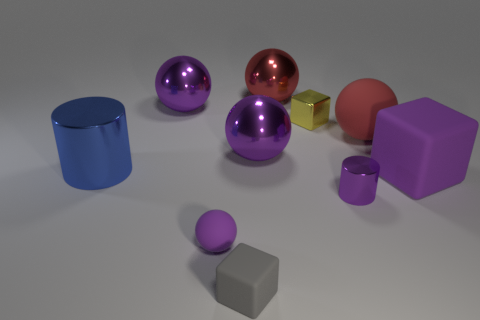Subtract all purple balls. How many were subtracted if there are1purple balls left? 2 Subtract all purple cylinders. How many purple spheres are left? 3 Subtract 1 spheres. How many spheres are left? 4 Subtract all blue balls. Subtract all green cubes. How many balls are left? 5 Subtract all blocks. How many objects are left? 7 Add 3 big balls. How many big balls are left? 7 Add 8 cyan shiny cylinders. How many cyan shiny cylinders exist? 8 Subtract 0 cyan blocks. How many objects are left? 10 Subtract all cubes. Subtract all red rubber balls. How many objects are left? 6 